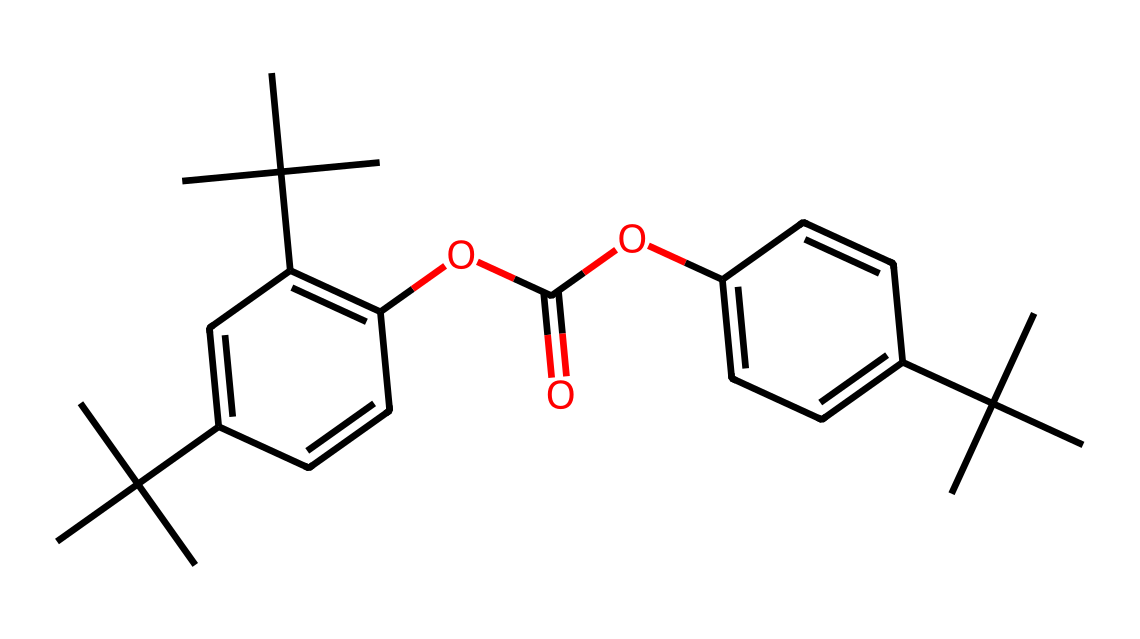How many carbon atoms are present in the structure? To determine the number of carbon atoms, count each carbon (C) symbol in the SMILES representation. There are a total of 27 carbon atoms in the given structure.
Answer: 27 What type of functional groups can be identified in this molecule? By examining the SMILES, we can see the presence of the ester group indicated by "OC(=O)O". This shows there are ester functionalities along with aromatic rings.
Answer: ester Which part of this chemical contributes to its rigidity? The presence of the aromatic rings (C1 and C2) in polycarbonate contributes significantly to the overall rigidity of the polymer structure.
Answer: aromatic rings What is the primary role of the molecule in protective eyewear? This polycarbonate structure provides high impact resistance and optical clarity, which are essential properties for protective eyewear.
Answer: impact resistance Is this chemical a thermoplastic? Compared to other types of plastics, polycarbonate is classified as a thermoplastic due to its ability to be reshaped upon heating.
Answer: thermoplastic How many double bonds are found in this structure? Analyzing the structure, we identify double bonds primarily in the aromatic rings (C=C). There are 4 double bonds present in total.
Answer: 4 Which group in this molecule makes it suitable for applications in phonetics research equipment? The clarity and durability provided by the polycarbonate structure, particularly its excellent optical properties, make it suitable for phonetics research equipment.
Answer: optical properties 